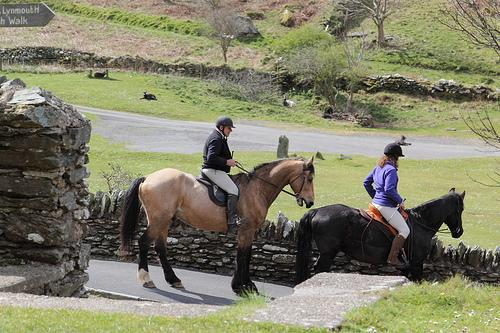What part of a horse's body is captured in more than one instance? The tail and ear of the horse are captured in more than one instance. What are the people in the image mainly engaged in? The people are mostly engaged in riding horses on a trail. What is the color of the pants a person involved with horses is wearing? A man interacting with horses is wearing brown pants. What type of head protection is someone wearing in the image? A man is wearing a black helmet in the image. Mention an accessory worn by the woman in the image. The woman is wearing a hat in the image. How many people are riding horses in the image? There are two people riding horses in the image. Describe the appearance of one of the horse's tails. There is a black fluffy hair of the horse's tail, possibly from the light brown horse. Describe the posture of the dark brown horse in the image The dark brown horse is captured in a trotting posture, with its mouth open. Identify the color of the horses in the image. There are a light brown horse and a dark brown horse in the image. Who is wearing white pants in the image? There is a woman wearing white pants in the image. 